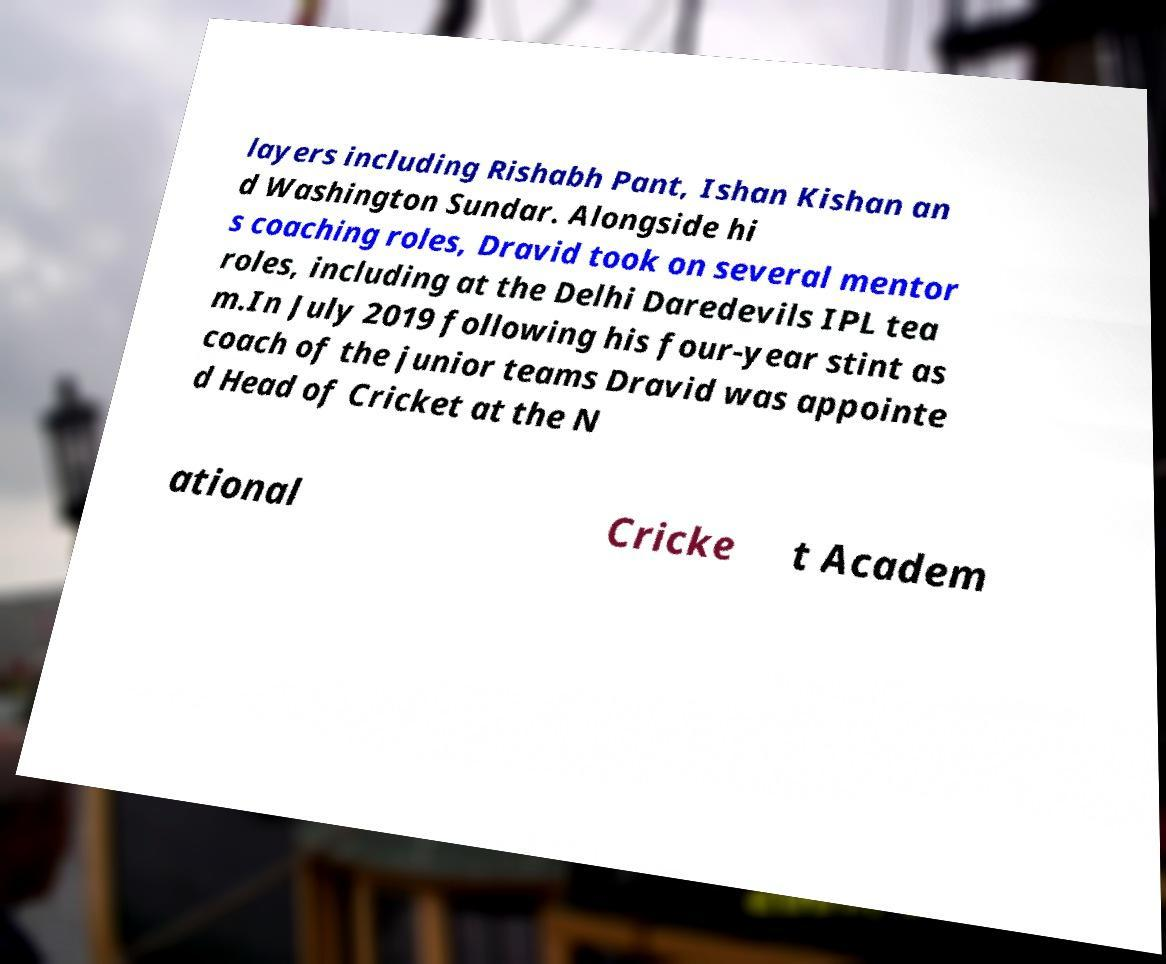Please identify and transcribe the text found in this image. layers including Rishabh Pant, Ishan Kishan an d Washington Sundar. Alongside hi s coaching roles, Dravid took on several mentor roles, including at the Delhi Daredevils IPL tea m.In July 2019 following his four-year stint as coach of the junior teams Dravid was appointe d Head of Cricket at the N ational Cricke t Academ 